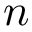<formula> <loc_0><loc_0><loc_500><loc_500>n</formula> 